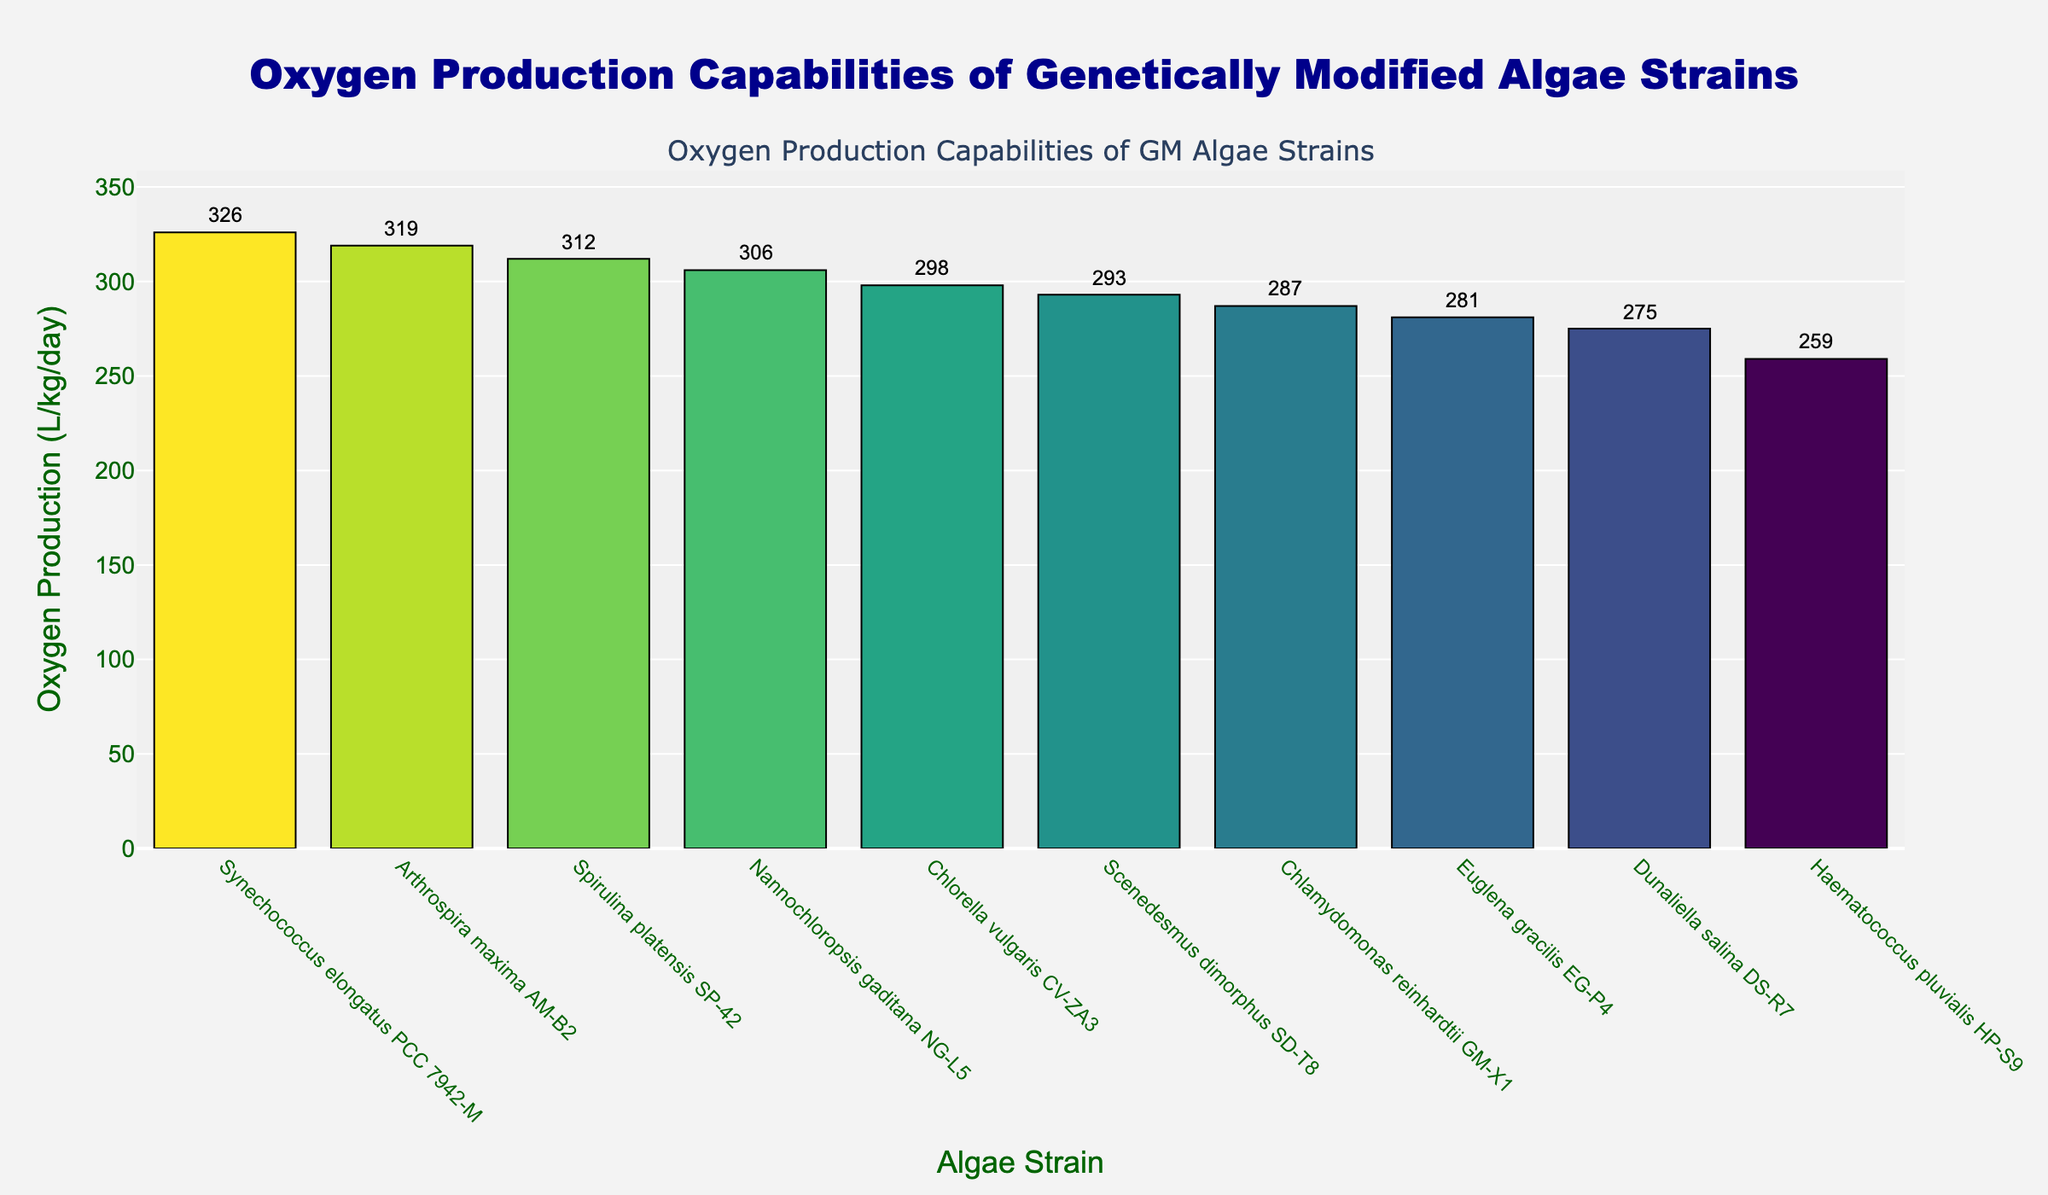Which genetically modified algae strain has the highest oxygen production? By looking at the bar chart, we can identify the strain with the tallest bar, indicating the highest oxygen production. In this case, the strain Spirulina platensis SP-42 has the highest oxygen production at 312 L/kg/day.
Answer: Spirulina platensis SP-42 Which genetically modified algae strain has the lowest oxygen production? The strain with the shortest bar on the chart represents the lowest oxygen production. Haematococcus pluvialis HP-S9 has the lowest oxygen production at 259 L/kg/day.
Answer: Haematococcus pluvialis HP-S9 What is the difference in oxygen production between the highest and lowest producing strains? The highest oxygen production is 312 L/kg/day by Spirulina platensis SP-42, and the lowest is 259 L/kg/day by Haematococcus pluvialis HP-S9. The difference is 312 - 259 = 53 L/kg/day.
Answer: 53 L/kg/day Which strains have an oxygen production of more than 300 L/kg/day? All strains with bars that extend beyond the 300 L/kg/day mark can be identified. These are Spirulina platensis SP-42, Synechococcus elongatus PCC 7942-M, Nannochloropsis gaditana NG-L5, and Arthrospira maxima AM-B2.
Answer: Spirulina platensis SP-42, Synechococcus elongatus PCC 7942-M, Nannochloropsis gaditana NG-L5, Arthrospira maxima AM-B2 How many strains have an oxygen production of more than 290 L/kg/day but less than 310 L/kg/day? Observing the bars within the range specified, the strains Chlorella vulgaris CV-ZA3 (298 L/kg/day), Nannochloropsis gaditana NG-L5 (306 L/kg/day), and Scenedesmus dimorphus SD-T8 (293 L/kg/day) fit this criteria. This gives us a total of 3 strains.
Answer: 3 strains What is the average oxygen production of all strains on the chart? To find the average, sum up all the strains' oxygen production values: 287 + 312 + 298 + 326 + 275 + 259 + 306 + 319 + 293 + 281 = 2956 L/kg/day. Then, divide by the number of strains (10): 2956 / 10 = 295.6 L/kg/day.
Answer: 295.6 L/kg/day How much more oxygen does Synechococcus elongatus PCC 7942-M produce compared to Chlamydomonas reinhardtii GM-X1? Synechococcus elongatus PCC 7942-M produces 326 L/kg/day, while Chlamydomonas reinhardtii GM-X1 produces 287 L/kg/day. The difference is 326 - 287 = 39 L/kg/day.
Answer: 39 L/kg/day Which genetically modified algae strains produce less than 280 L/kg/day? Identifying the bars that are shorter than the 280 mark, we find Dunaliella salina DS-R7 (275 L/kg/day) and Haematococcus pluvialis HP-S9 (259 L/kg/day).
Answer: Dunaliella salina DS-R7, Haematococcus pluvialis HP-S9 